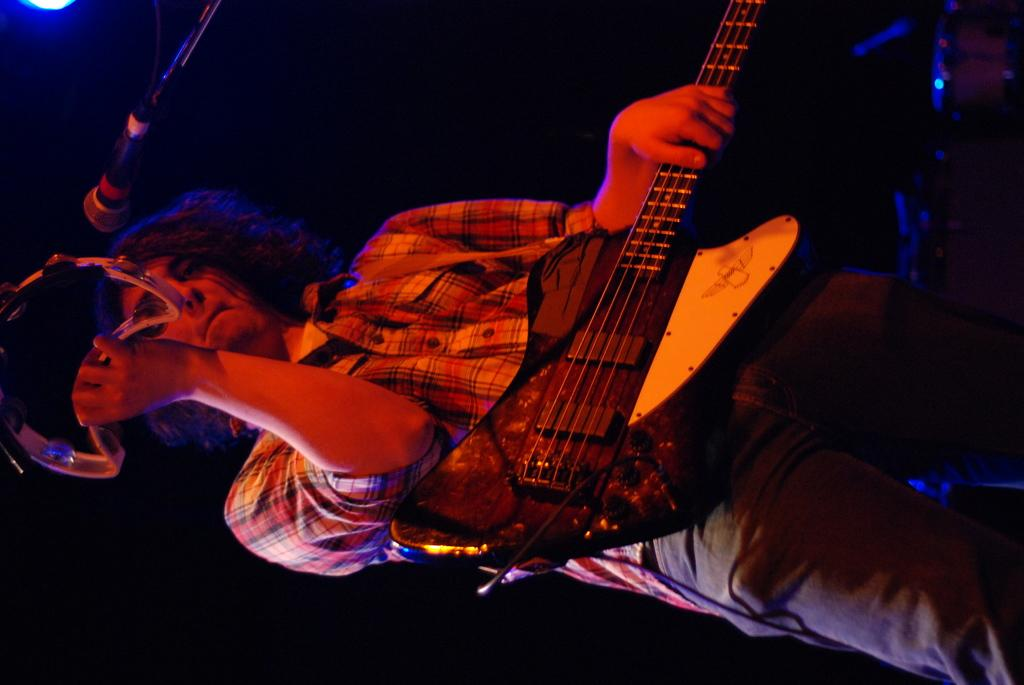What is the main subject of the image? The main subject of the image is a man. What is the man doing in the image? The man is standing and playing a tambourine. What instrument is the man holding in his hand? The man is holding a guitar in his hand. What object is placed before the man? There is a microphone placed before him. What type of boundary can be seen in the image? There is no boundary present in the image. Is there a stream visible in the image? No, there is no stream visible in the image. 